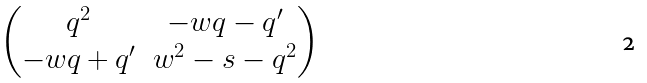<formula> <loc_0><loc_0><loc_500><loc_500>\begin{pmatrix} q ^ { 2 } & - w q - q ^ { \prime } \\ - w q + q ^ { \prime } & w ^ { 2 } - s - q ^ { 2 } \end{pmatrix}</formula> 